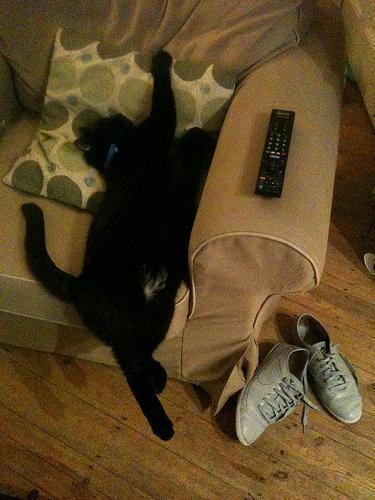How many remotes are there?
Give a very brief answer. 1. How many pillows are on the couch?
Give a very brief answer. 1. How many shoes are there?
Give a very brief answer. 2. 